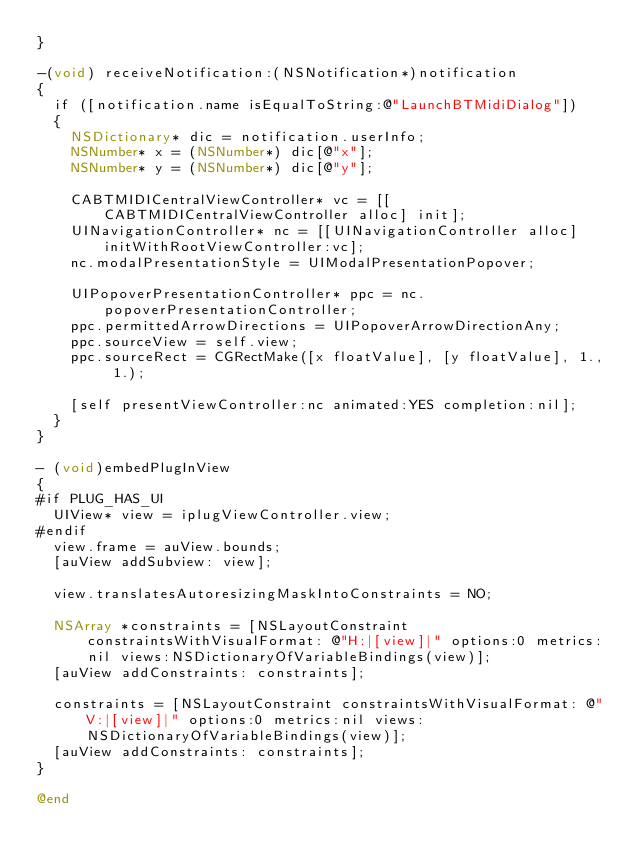Convert code to text. <code><loc_0><loc_0><loc_500><loc_500><_ObjectiveC_>}

-(void) receiveNotification:(NSNotification*)notification
{
  if ([notification.name isEqualToString:@"LaunchBTMidiDialog"])
  {
    NSDictionary* dic = notification.userInfo;
    NSNumber* x = (NSNumber*) dic[@"x"];
    NSNumber* y = (NSNumber*) dic[@"y"];
   
    CABTMIDICentralViewController* vc = [[CABTMIDICentralViewController alloc] init];
    UINavigationController* nc = [[UINavigationController alloc] initWithRootViewController:vc];
    nc.modalPresentationStyle = UIModalPresentationPopover;
    
    UIPopoverPresentationController* ppc = nc.popoverPresentationController;
    ppc.permittedArrowDirections = UIPopoverArrowDirectionAny;
    ppc.sourceView = self.view;
    ppc.sourceRect = CGRectMake([x floatValue], [y floatValue], 1., 1.);
    
    [self presentViewController:nc animated:YES completion:nil];
  }
}

- (void)embedPlugInView
{
#if PLUG_HAS_UI
  UIView* view = iplugViewController.view;
#endif
  view.frame = auView.bounds;
  [auView addSubview: view];

  view.translatesAutoresizingMaskIntoConstraints = NO;

  NSArray *constraints = [NSLayoutConstraint constraintsWithVisualFormat: @"H:|[view]|" options:0 metrics:nil views:NSDictionaryOfVariableBindings(view)];
  [auView addConstraints: constraints];

  constraints = [NSLayoutConstraint constraintsWithVisualFormat: @"V:|[view]|" options:0 metrics:nil views:NSDictionaryOfVariableBindings(view)];
  [auView addConstraints: constraints];
}

@end

</code> 